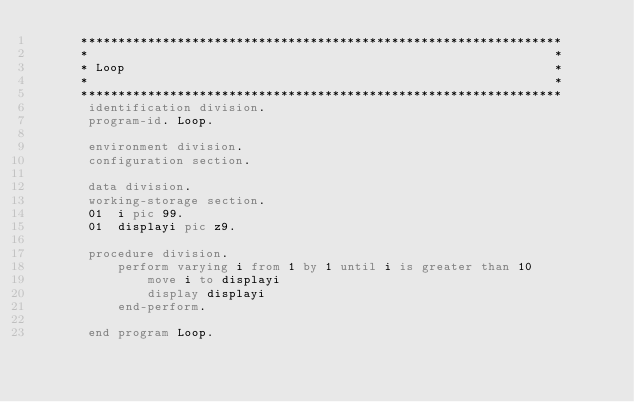Convert code to text. <code><loc_0><loc_0><loc_500><loc_500><_COBOL_>      *****************************************************************
      *                                                               *
      * Loop                                                          *
      *                                                               *
      *****************************************************************
       identification division.
       program-id. Loop.

       environment division.
       configuration section.

       data division.
       working-storage section.
       01  i pic 99.
       01  displayi pic z9.
       
       procedure division.
           perform varying i from 1 by 1 until i is greater than 10
               move i to displayi
               display displayi
           end-perform.
       
       end program Loop.</code> 